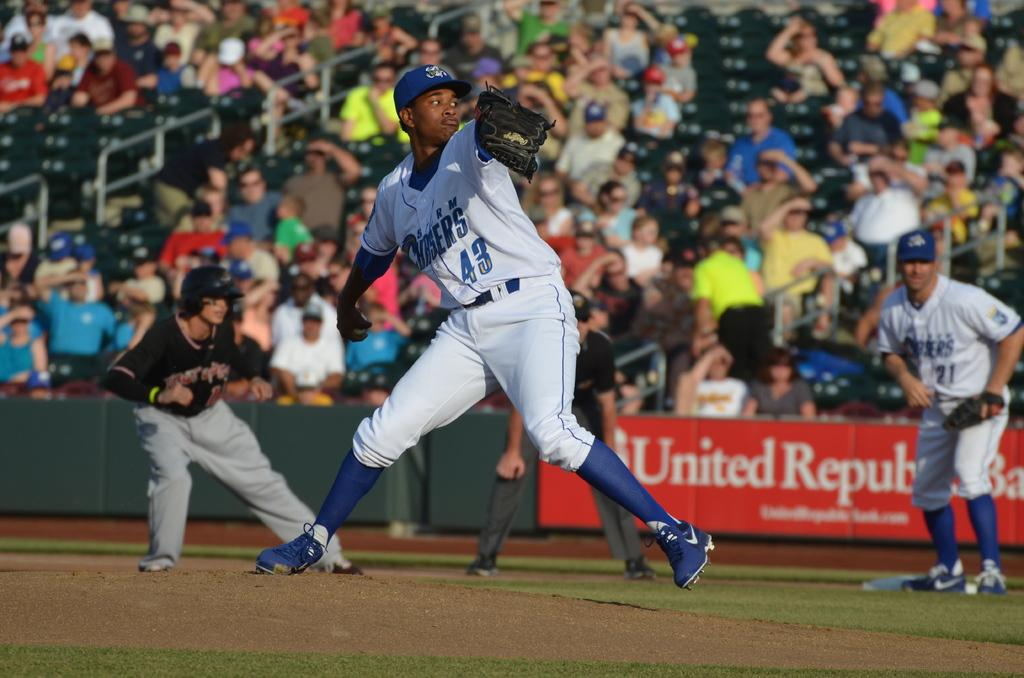<image>
Describe the image concisely. Player number 43 is winding up for the pitch in a baseball game. 